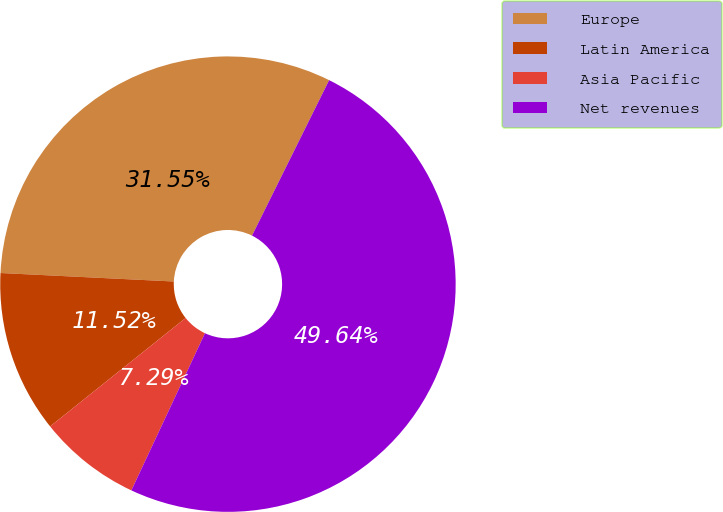Convert chart. <chart><loc_0><loc_0><loc_500><loc_500><pie_chart><fcel>Europe<fcel>Latin America<fcel>Asia Pacific<fcel>Net revenues<nl><fcel>31.55%<fcel>11.52%<fcel>7.29%<fcel>49.64%<nl></chart> 